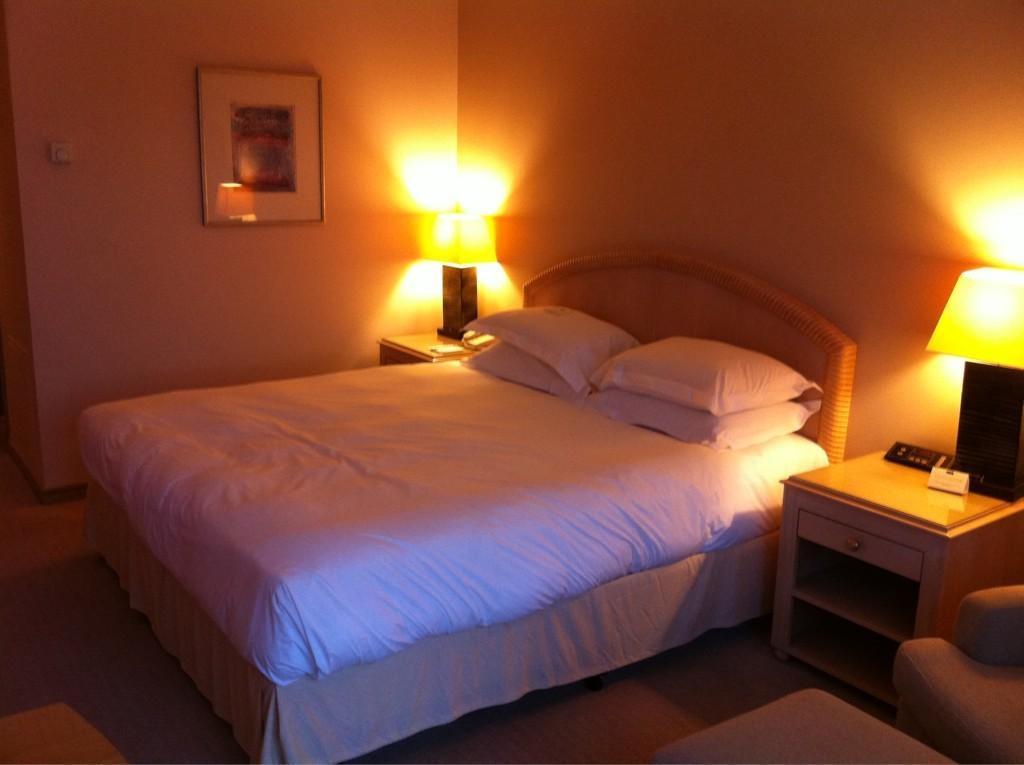Can you describe this image briefly? Here we can see a bed with pillows on it and there are lights, lamps placed on either side of the bed and on the wall we can see a portrait 